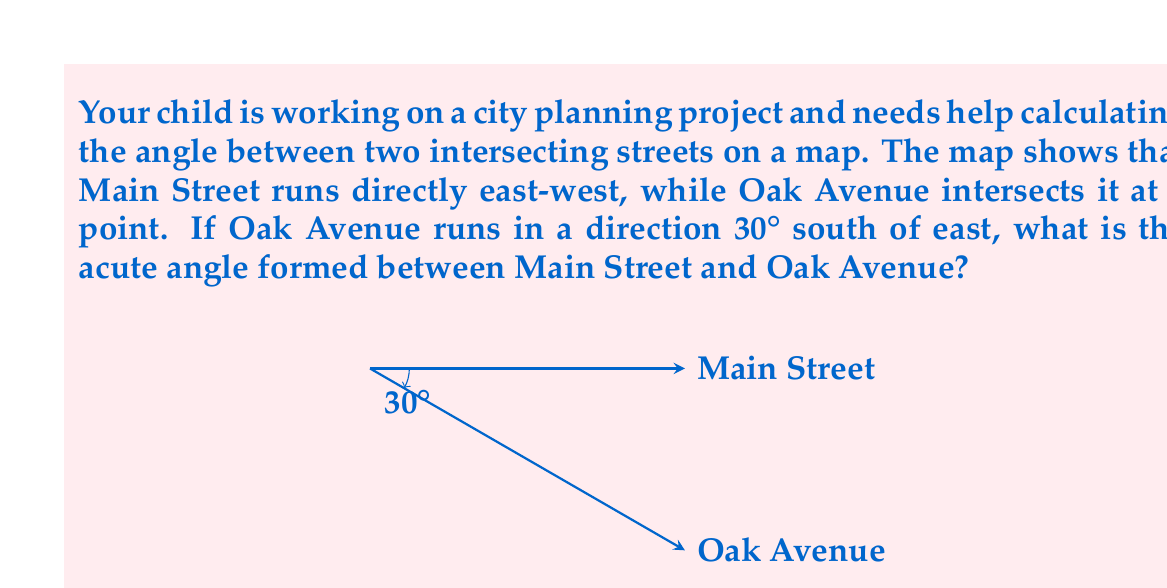Show me your answer to this math problem. Let's approach this step-by-step:

1) First, we need to understand what the question is asking. We're looking for the acute angle between two streets, where one street (Main Street) runs east-west, and the other (Oak Avenue) runs 30° south of east.

2) In geometry, when two lines intersect, they form four angles. The acute angle is the smaller of the two angles formed.

3) We're told that Oak Avenue runs 30° south of east. This means it makes a 30° angle with the eastward direction, but in the downward (southward) direction.

4) Main Street runs east-west, which we can consider as our reference line at 0°.

5) To find the angle between the two streets, we need to subtract the angle of Oak Avenue from the angle of Main Street:

   $$ \text{Angle between streets} = 0° - (-30°) = 30° $$

6) Note that we use -30° for Oak Avenue because it's 30° south (below) the east-west line.

7) The acute angle formed between the streets is therefore 30°.

This problem demonstrates how geometry applies to real-world scenarios like urban planning, showing your child that math has practical applications beyond the classroom.
Answer: 30° 